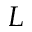<formula> <loc_0><loc_0><loc_500><loc_500>L</formula> 